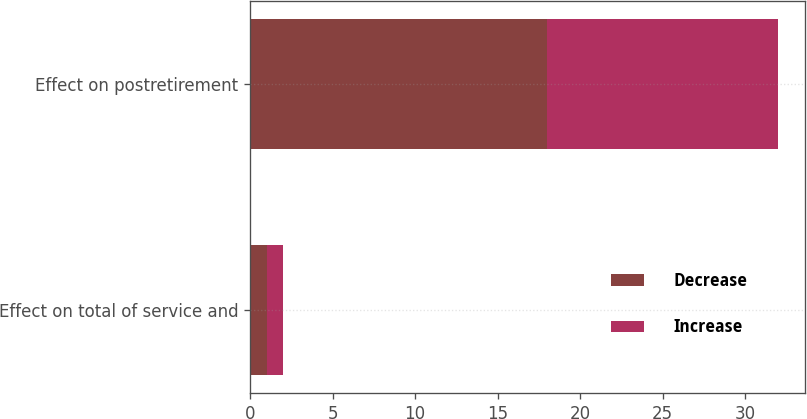<chart> <loc_0><loc_0><loc_500><loc_500><stacked_bar_chart><ecel><fcel>Effect on total of service and<fcel>Effect on postretirement<nl><fcel>Decrease<fcel>1<fcel>18<nl><fcel>Increase<fcel>1<fcel>14<nl></chart> 